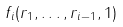Convert formula to latex. <formula><loc_0><loc_0><loc_500><loc_500>f _ { i } ( r _ { 1 } , \dots , r _ { i - 1 } , 1 )</formula> 